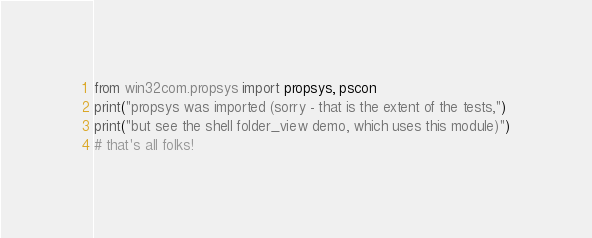<code> <loc_0><loc_0><loc_500><loc_500><_Python_>from win32com.propsys import propsys, pscon
print("propsys was imported (sorry - that is the extent of the tests,")
print("but see the shell folder_view demo, which uses this module)")
# that's all folks!</code> 